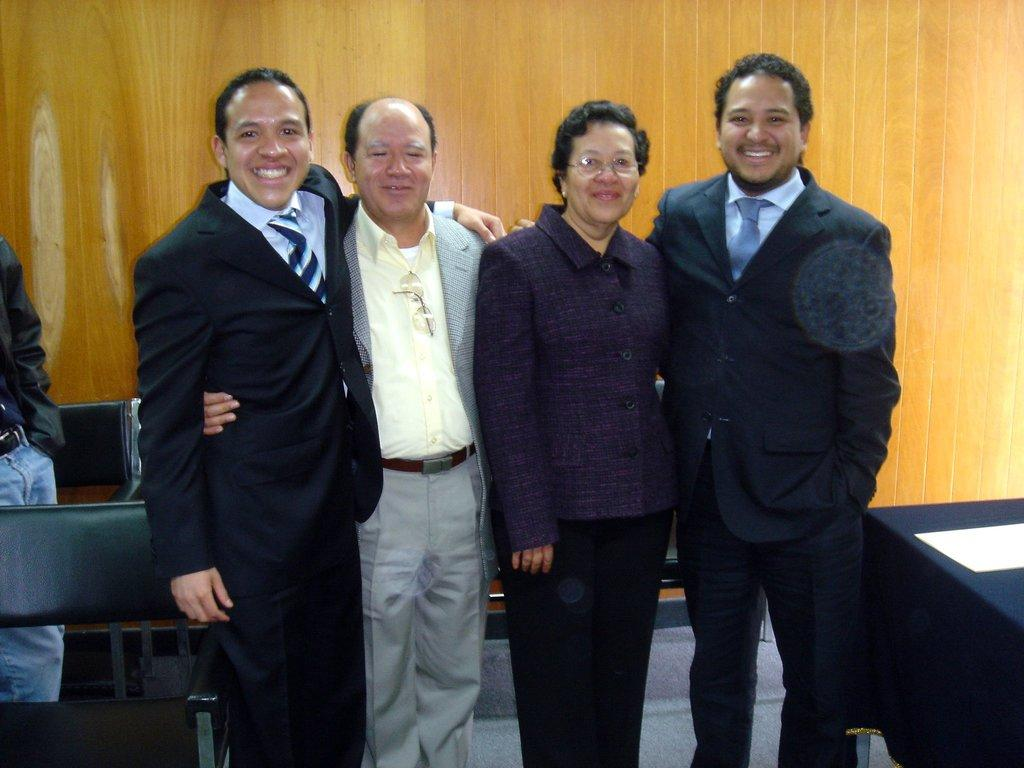How many people are in the foreground of the image? There are three men and a woman in the foreground of the image. What are the people in the foreground doing? The people are standing and smiling. What can be seen in the background of the image? There is a table, benches, a man, and a wooden wall in the background of the image. What type of ticket is the woman holding in the image? There is no ticket present in the image. What is the woman's interest in the man standing in the background? The image does not provide any information about the woman's interest in the man standing in the background. 